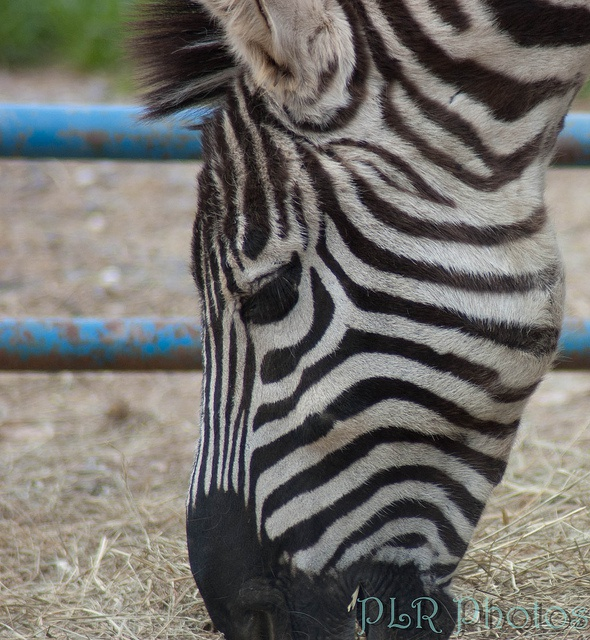Describe the objects in this image and their specific colors. I can see a zebra in darkgreen, black, darkgray, and gray tones in this image. 